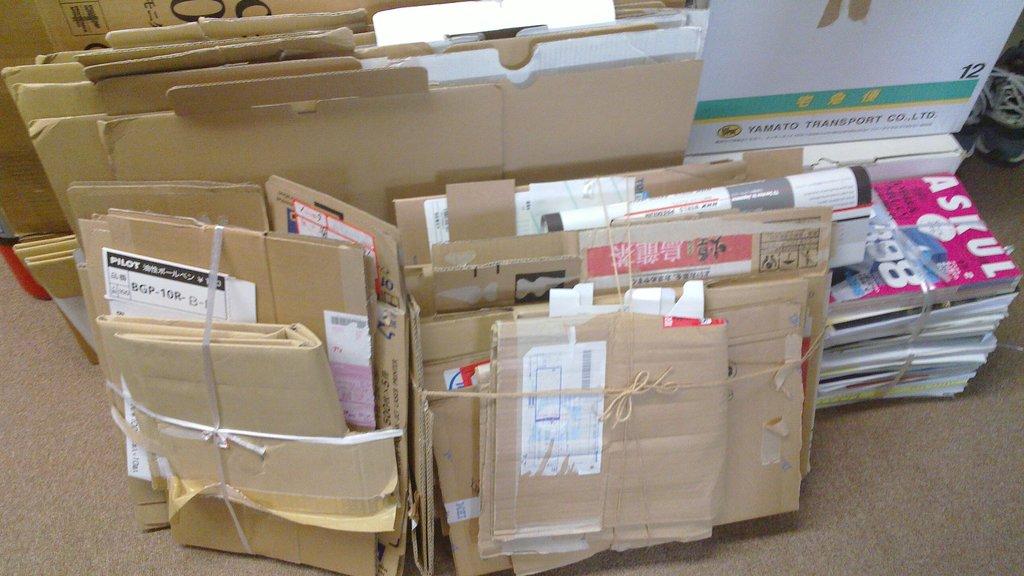What company transports the top right box?
Keep it short and to the point. Yamato. What is the name of the pink magazine?
Provide a short and direct response. Askul. 